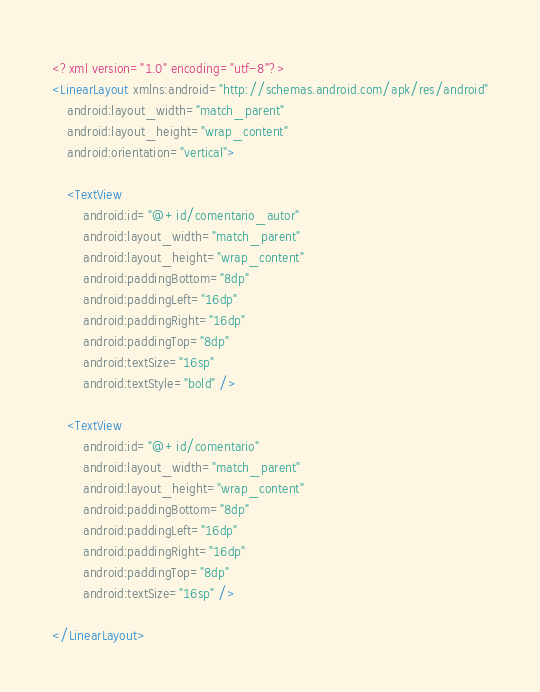<code> <loc_0><loc_0><loc_500><loc_500><_XML_><?xml version="1.0" encoding="utf-8"?>
<LinearLayout xmlns:android="http://schemas.android.com/apk/res/android"
    android:layout_width="match_parent"
    android:layout_height="wrap_content"
    android:orientation="vertical">

    <TextView
        android:id="@+id/comentario_autor"
        android:layout_width="match_parent"
        android:layout_height="wrap_content"
        android:paddingBottom="8dp"
        android:paddingLeft="16dp"
        android:paddingRight="16dp"
        android:paddingTop="8dp"
        android:textSize="16sp"
        android:textStyle="bold" />

    <TextView
        android:id="@+id/comentario"
        android:layout_width="match_parent"
        android:layout_height="wrap_content"
        android:paddingBottom="8dp"
        android:paddingLeft="16dp"
        android:paddingRight="16dp"
        android:paddingTop="8dp"
        android:textSize="16sp" />

</LinearLayout></code> 